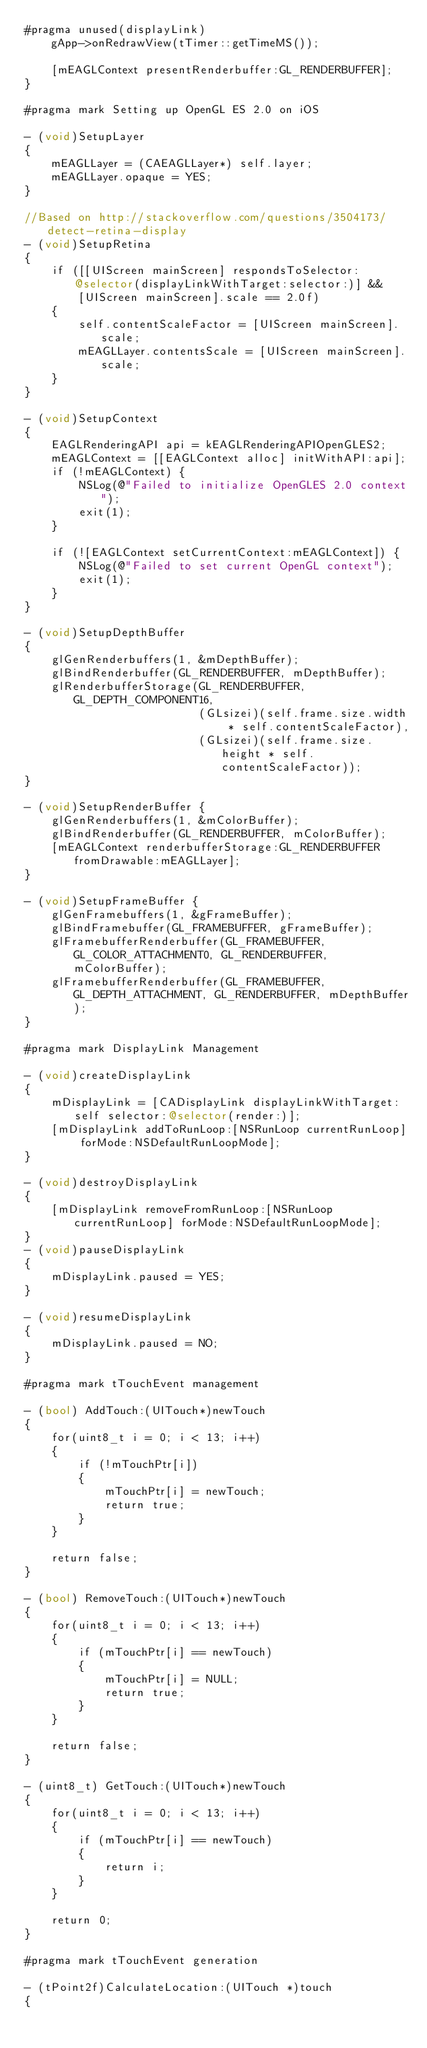<code> <loc_0><loc_0><loc_500><loc_500><_ObjectiveC_>#pragma unused(displayLink)
    gApp->onRedrawView(tTimer::getTimeMS());
    
    [mEAGLContext presentRenderbuffer:GL_RENDERBUFFER];
}

#pragma mark Setting up OpenGL ES 2.0 on iOS

- (void)SetupLayer
{
    mEAGLLayer = (CAEAGLLayer*) self.layer;
    mEAGLLayer.opaque = YES;
}

//Based on http://stackoverflow.com/questions/3504173/detect-retina-display
- (void)SetupRetina
{
    if ([[UIScreen mainScreen] respondsToSelector:@selector(displayLinkWithTarget:selector:)] &&
        [UIScreen mainScreen].scale == 2.0f)
    {
        self.contentScaleFactor = [UIScreen mainScreen].scale;
        mEAGLLayer.contentsScale = [UIScreen mainScreen].scale;
    }
}

- (void)SetupContext
{
    EAGLRenderingAPI api = kEAGLRenderingAPIOpenGLES2;
    mEAGLContext = [[EAGLContext alloc] initWithAPI:api];
    if (!mEAGLContext) {
        NSLog(@"Failed to initialize OpenGLES 2.0 context");
        exit(1);
    }
    
    if (![EAGLContext setCurrentContext:mEAGLContext]) {
        NSLog(@"Failed to set current OpenGL context");
        exit(1);
    }
}

- (void)SetupDepthBuffer
{
    glGenRenderbuffers(1, &mDepthBuffer);
    glBindRenderbuffer(GL_RENDERBUFFER, mDepthBuffer);
    glRenderbufferStorage(GL_RENDERBUFFER, GL_DEPTH_COMPONENT16,
                          (GLsizei)(self.frame.size.width * self.contentScaleFactor),
                          (GLsizei)(self.frame.size.height * self.contentScaleFactor));
}

- (void)SetupRenderBuffer {
    glGenRenderbuffers(1, &mColorBuffer);
    glBindRenderbuffer(GL_RENDERBUFFER, mColorBuffer);        
    [mEAGLContext renderbufferStorage:GL_RENDERBUFFER fromDrawable:mEAGLLayer];    
}

- (void)SetupFrameBuffer {    
    glGenFramebuffers(1, &gFrameBuffer);
    glBindFramebuffer(GL_FRAMEBUFFER, gFrameBuffer);   
    glFramebufferRenderbuffer(GL_FRAMEBUFFER, GL_COLOR_ATTACHMENT0, GL_RENDERBUFFER, mColorBuffer);
    glFramebufferRenderbuffer(GL_FRAMEBUFFER, GL_DEPTH_ATTACHMENT, GL_RENDERBUFFER, mDepthBuffer);
}

#pragma mark DisplayLink Management

- (void)createDisplayLink
{
    mDisplayLink = [CADisplayLink displayLinkWithTarget:self selector:@selector(render:)];
    [mDisplayLink addToRunLoop:[NSRunLoop currentRunLoop] forMode:NSDefaultRunLoopMode];    
}

- (void)destroyDisplayLink
{
    [mDisplayLink removeFromRunLoop:[NSRunLoop currentRunLoop] forMode:NSDefaultRunLoopMode];
}
- (void)pauseDisplayLink
{
    mDisplayLink.paused = YES;
}

- (void)resumeDisplayLink
{
    mDisplayLink.paused = NO;
}

#pragma mark tTouchEvent management

- (bool) AddTouch:(UITouch*)newTouch
{
    for(uint8_t i = 0; i < 13; i++)
    {
        if (!mTouchPtr[i])
        {
            mTouchPtr[i] = newTouch;
            return true;
        }
    }

    return false;
}

- (bool) RemoveTouch:(UITouch*)newTouch
{
    for(uint8_t i = 0; i < 13; i++)
    {
        if (mTouchPtr[i] == newTouch)
        {
            mTouchPtr[i] = NULL;
            return true;
        }
    }

    return false;
}

- (uint8_t) GetTouch:(UITouch*)newTouch
{
    for(uint8_t i = 0; i < 13; i++)
    {
        if (mTouchPtr[i] == newTouch)
        {
            return i;
        }
    }

    return 0;
}

#pragma mark tTouchEvent generation

- (tPoint2f)CalculateLocation:(UITouch *)touch
{</code> 